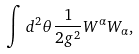Convert formula to latex. <formula><loc_0><loc_0><loc_500><loc_500>\int d ^ { 2 } \theta \frac { 1 } { 2 g ^ { 2 } } W ^ { \alpha } W _ { \alpha } ,</formula> 